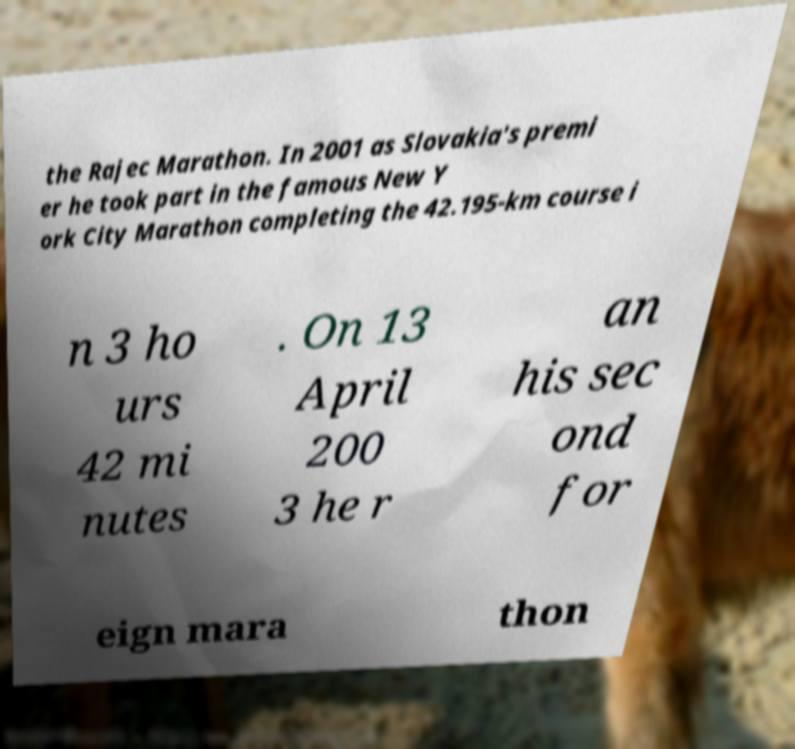Could you assist in decoding the text presented in this image and type it out clearly? the Rajec Marathon. In 2001 as Slovakia's premi er he took part in the famous New Y ork City Marathon completing the 42.195-km course i n 3 ho urs 42 mi nutes . On 13 April 200 3 he r an his sec ond for eign mara thon 